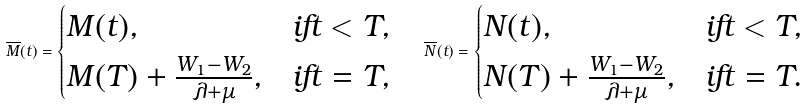<formula> <loc_0><loc_0><loc_500><loc_500>\overline { M } ( t ) = \begin{cases} M ( t ) , & i f t < T , \\ M ( T ) + \frac { W _ { 1 } - W _ { 2 } } { \lambda + \mu } , & i f t = T , \end{cases} \quad \overline { N } ( t ) = \begin{cases} N ( t ) , & i f t < T , \\ N ( T ) + \frac { W _ { 1 } - W _ { 2 } } { \lambda + \mu } , & i f t = T . \end{cases}</formula> 